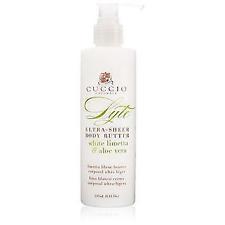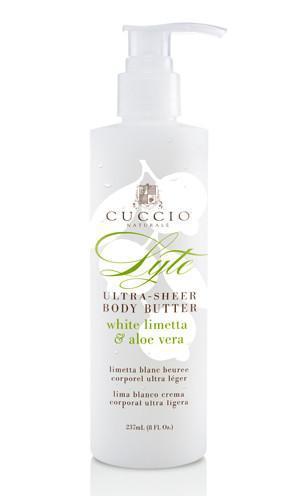The first image is the image on the left, the second image is the image on the right. Evaluate the accuracy of this statement regarding the images: "One bottle has yellow lemons on it.". Is it true? Answer yes or no. No. 